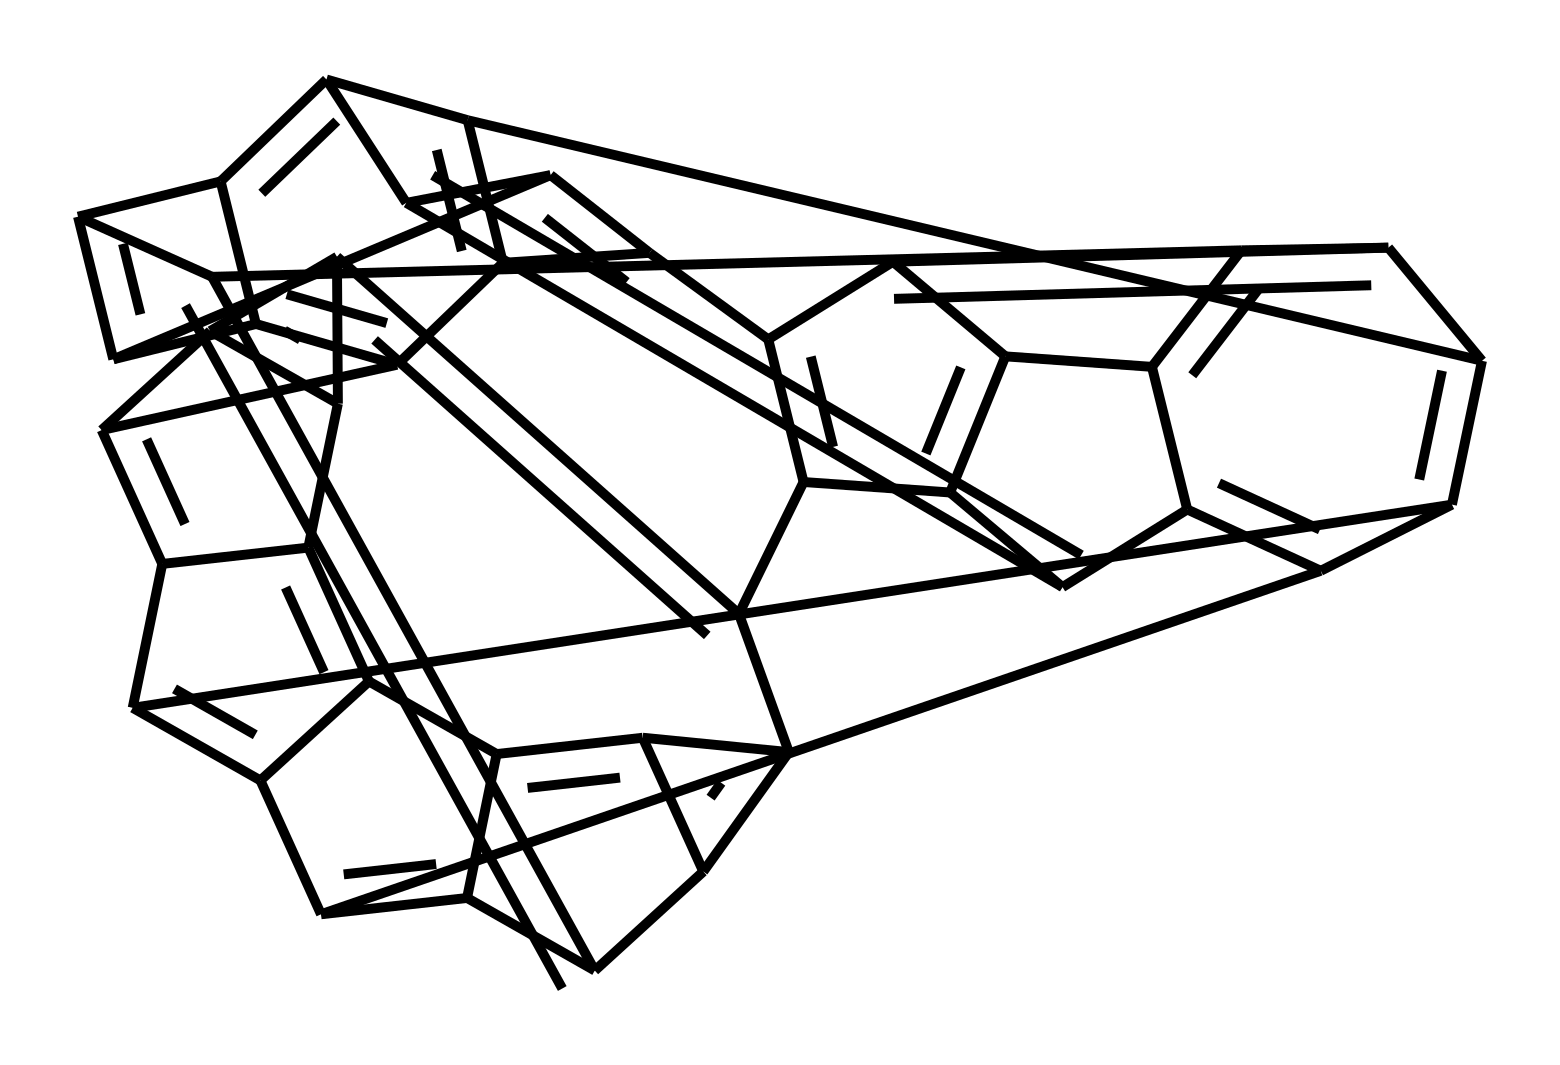What is the overall shape of this fullerene? The structure depicted is a spherical arrangement, typical for fullerenes, resembling a hollow sphere or ball, consistent with the nature of C60 molecules, which exhibit a soccer ball shape.
Answer: spherical How many carbon atoms are present in this fullerene structure? By examining the SMILES notation and counting the carbon atoms, we find there are 60 carbon atoms as indicated by the repetitive elements in the SMILES.
Answer: 60 What type of bonding is primarily found in fullerenes? Fullerenes primarily feature sp2 hybridized carbon-carbon bonding, creating a network of double bonds and single bonds, characteristic of their unique stability and structure.
Answer: sp2 Does this structure have any functional groups? The chemical structure represented does not show any functional groups such as -OH, -COOH, etc., indicating it is a pure fullerene without additional functionalization.
Answer: no What is the primary application of fullerene-infused fabrics? Fullerene-infused fabrics are primarily used for moisture-wicking applications, leveraging the unique properties of fullerenes to enhance the performance of athletic wear.
Answer: moisture-wicking What advantages do fullerenes confer to athletic wear? The incorporation of fullerenes in athletic fabrics enhances durability and moisture management, allowing for improved performance and comfort during activities such as running.
Answer: durability 